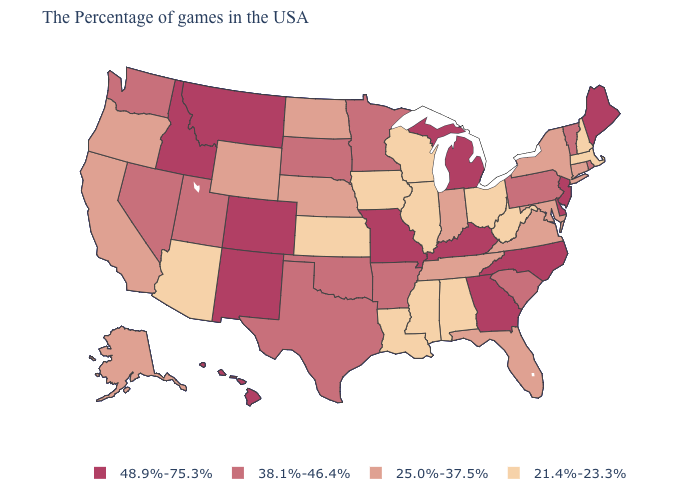Is the legend a continuous bar?
Keep it brief. No. Does Virginia have the same value as Nevada?
Concise answer only. No. Does the first symbol in the legend represent the smallest category?
Be succinct. No. What is the value of Iowa?
Write a very short answer. 21.4%-23.3%. How many symbols are there in the legend?
Answer briefly. 4. Does Arizona have the highest value in the West?
Write a very short answer. No. What is the value of Tennessee?
Give a very brief answer. 25.0%-37.5%. Does Montana have a lower value than Wisconsin?
Be succinct. No. Name the states that have a value in the range 21.4%-23.3%?
Keep it brief. Massachusetts, New Hampshire, West Virginia, Ohio, Alabama, Wisconsin, Illinois, Mississippi, Louisiana, Iowa, Kansas, Arizona. Among the states that border North Dakota , which have the lowest value?
Answer briefly. Minnesota, South Dakota. Which states have the lowest value in the MidWest?
Concise answer only. Ohio, Wisconsin, Illinois, Iowa, Kansas. What is the value of South Carolina?
Quick response, please. 38.1%-46.4%. What is the value of South Dakota?
Concise answer only. 38.1%-46.4%. Does Minnesota have the highest value in the USA?
Quick response, please. No. What is the highest value in the West ?
Keep it brief. 48.9%-75.3%. 